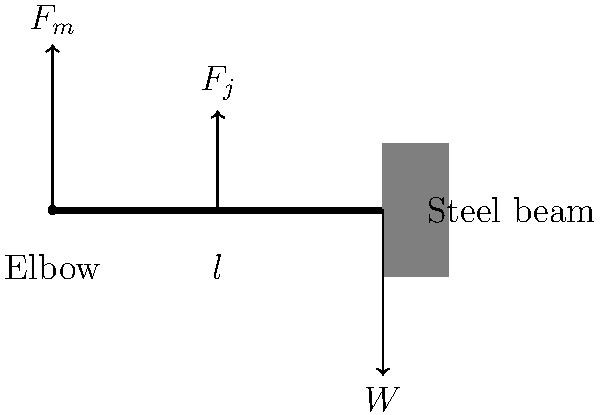A steelworker is lifting a heavy steel beam using their arm. The steel beam weighs 500 N and is held at a distance of 0.5 m from the elbow joint. The biceps muscle attaches to the forearm 0.05 m from the elbow joint. Calculate the force exerted by the biceps muscle to hold the steel beam in a static position, assuming the forearm weighs 20 N with its center of mass 0.25 m from the elbow. To solve this problem, we'll use the principle of moments about the elbow joint:

1. Identify the forces acting on the arm:
   - Weight of the steel beam (W): 500 N
   - Weight of the forearm (W_f): 20 N
   - Force exerted by the biceps muscle (F_m)

2. Calculate the moments about the elbow joint:
   - Moment due to steel beam: $M_W = 500 \text{ N} \times 0.5 \text{ m} = 250 \text{ N⋅m}$
   - Moment due to forearm weight: $M_{W_f} = 20 \text{ N} \times 0.25 \text{ m} = 5 \text{ N⋅m}$
   - Moment due to biceps force: $M_m = F_m \times 0.05 \text{ m}$

3. Apply the principle of moments (clockwise moments = counterclockwise moments):
   $M_m = M_W + M_{W_f}$
   $F_m \times 0.05 \text{ m} = 250 \text{ N⋅m} + 5 \text{ N⋅m}$
   $F_m \times 0.05 \text{ m} = 255 \text{ N⋅m}$

4. Solve for F_m:
   $F_m = \frac{255 \text{ N⋅m}}{0.05 \text{ m}} = 5100 \text{ N}$

Therefore, the force exerted by the biceps muscle to hold the steel beam in a static position is 5100 N.
Answer: 5100 N 